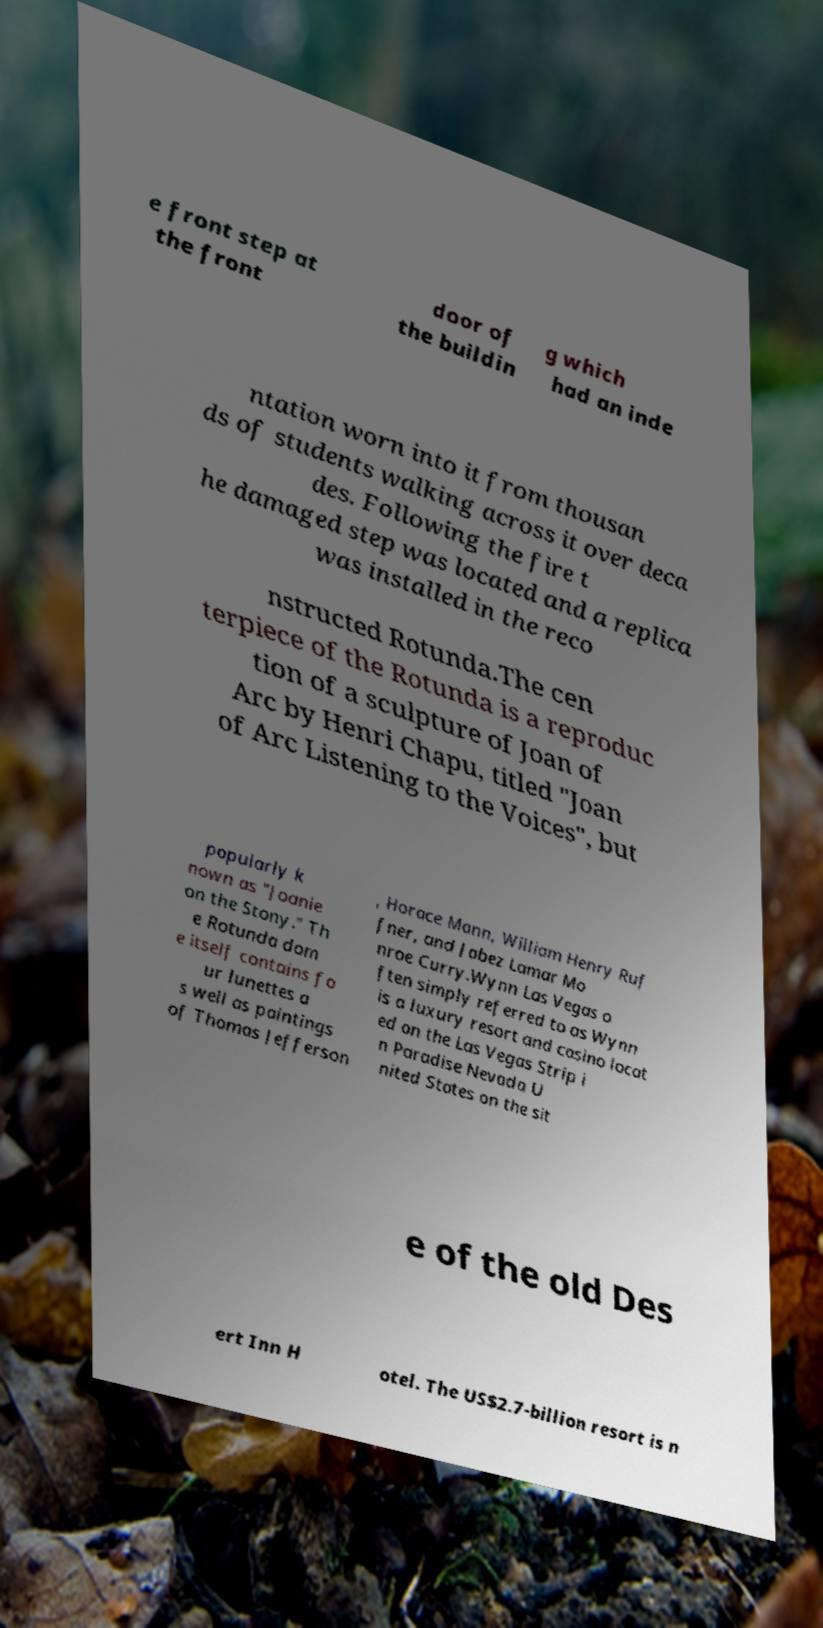There's text embedded in this image that I need extracted. Can you transcribe it verbatim? e front step at the front door of the buildin g which had an inde ntation worn into it from thousan ds of students walking across it over deca des. Following the fire t he damaged step was located and a replica was installed in the reco nstructed Rotunda.The cen terpiece of the Rotunda is a reproduc tion of a sculpture of Joan of Arc by Henri Chapu, titled "Joan of Arc Listening to the Voices", but popularly k nown as "Joanie on the Stony." Th e Rotunda dom e itself contains fo ur lunettes a s well as paintings of Thomas Jefferson , Horace Mann, William Henry Ruf fner, and Jabez Lamar Mo nroe Curry.Wynn Las Vegas o ften simply referred to as Wynn is a luxury resort and casino locat ed on the Las Vegas Strip i n Paradise Nevada U nited States on the sit e of the old Des ert Inn H otel. The US$2.7-billion resort is n 